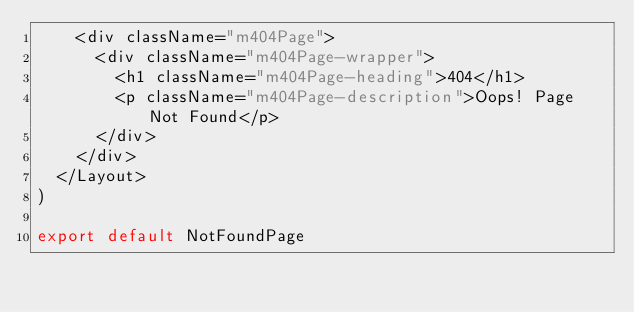Convert code to text. <code><loc_0><loc_0><loc_500><loc_500><_JavaScript_>    <div className="m404Page">
      <div className="m404Page-wrapper">
        <h1 className="m404Page-heading">404</h1>
        <p className="m404Page-description">Oops! Page Not Found</p>
      </div>
    </div>
  </Layout>
)

export default NotFoundPage
</code> 